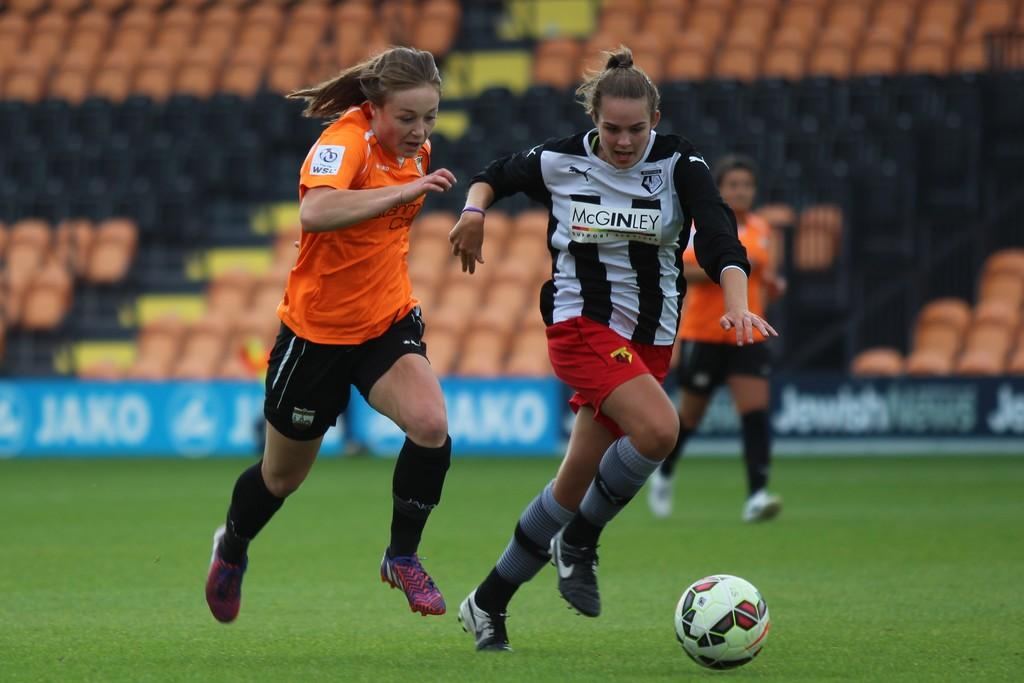<image>
Create a compact narrative representing the image presented. Three female soccer players dressed in McGinley and WSL uniforms and cleats chasing after a soccer ball. 